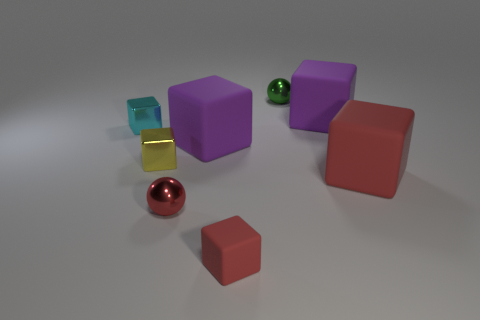The tiny shiny thing in front of the small yellow metallic thing has what shape? sphere 